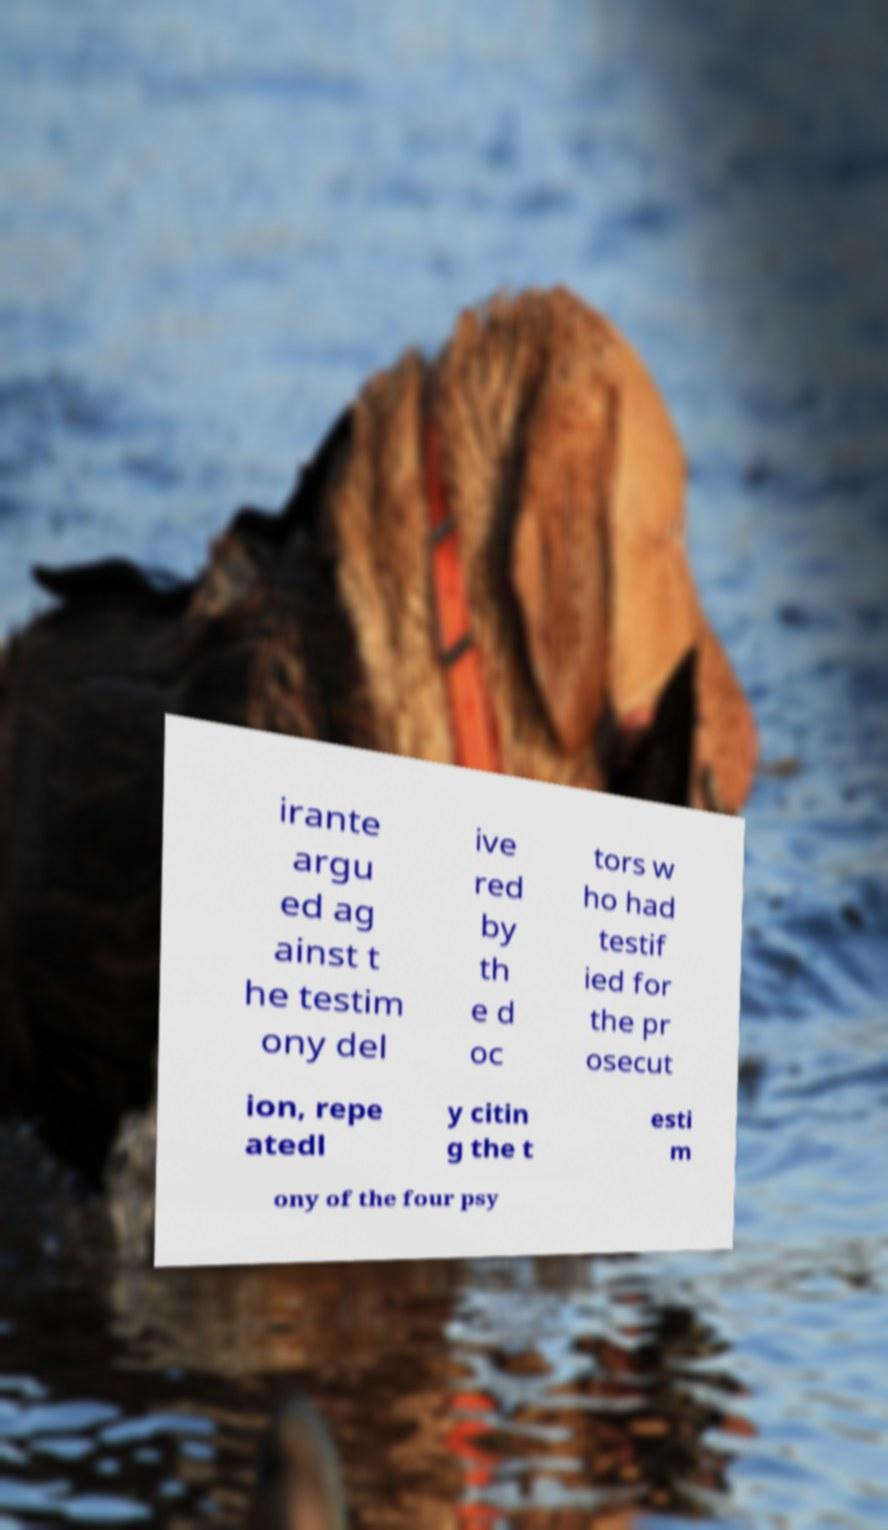Please read and relay the text visible in this image. What does it say? irante argu ed ag ainst t he testim ony del ive red by th e d oc tors w ho had testif ied for the pr osecut ion, repe atedl y citin g the t esti m ony of the four psy 